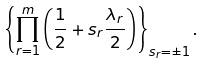<formula> <loc_0><loc_0><loc_500><loc_500>\left \{ \prod _ { r = 1 } ^ { m } \left ( \frac { 1 } { 2 } + s _ { r } \frac { \lambda _ { r } } { 2 } \right ) \right \} _ { s _ { r } = \pm 1 } .</formula> 